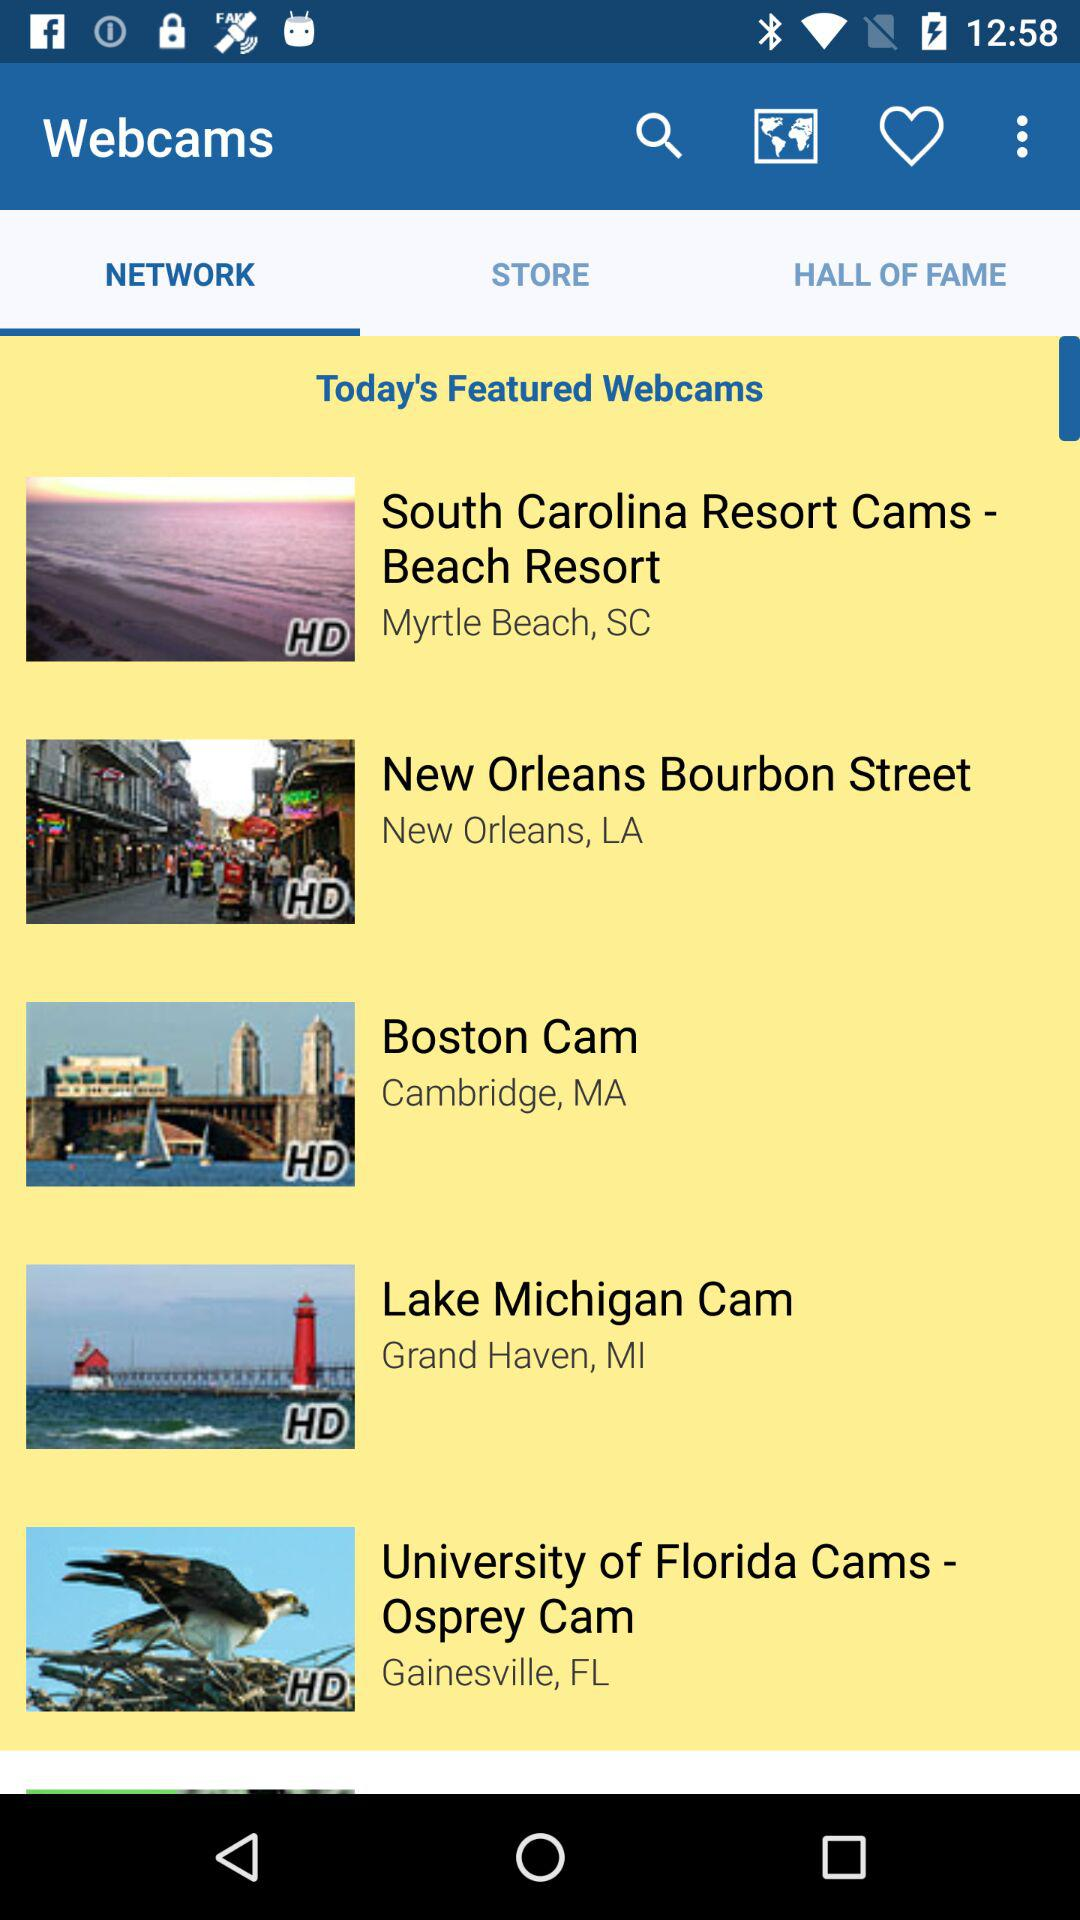How many webcams are featured in the today's featured section?
Answer the question using a single word or phrase. 5 